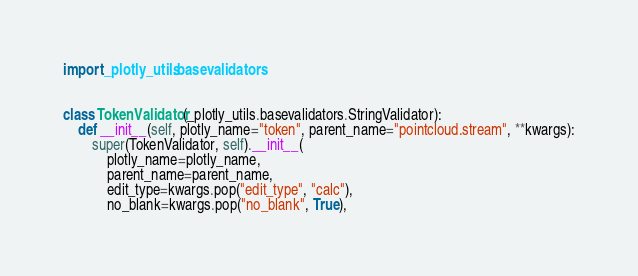Convert code to text. <code><loc_0><loc_0><loc_500><loc_500><_Python_>import _plotly_utils.basevalidators


class TokenValidator(_plotly_utils.basevalidators.StringValidator):
    def __init__(self, plotly_name="token", parent_name="pointcloud.stream", **kwargs):
        super(TokenValidator, self).__init__(
            plotly_name=plotly_name,
            parent_name=parent_name,
            edit_type=kwargs.pop("edit_type", "calc"),
            no_blank=kwargs.pop("no_blank", True),</code> 